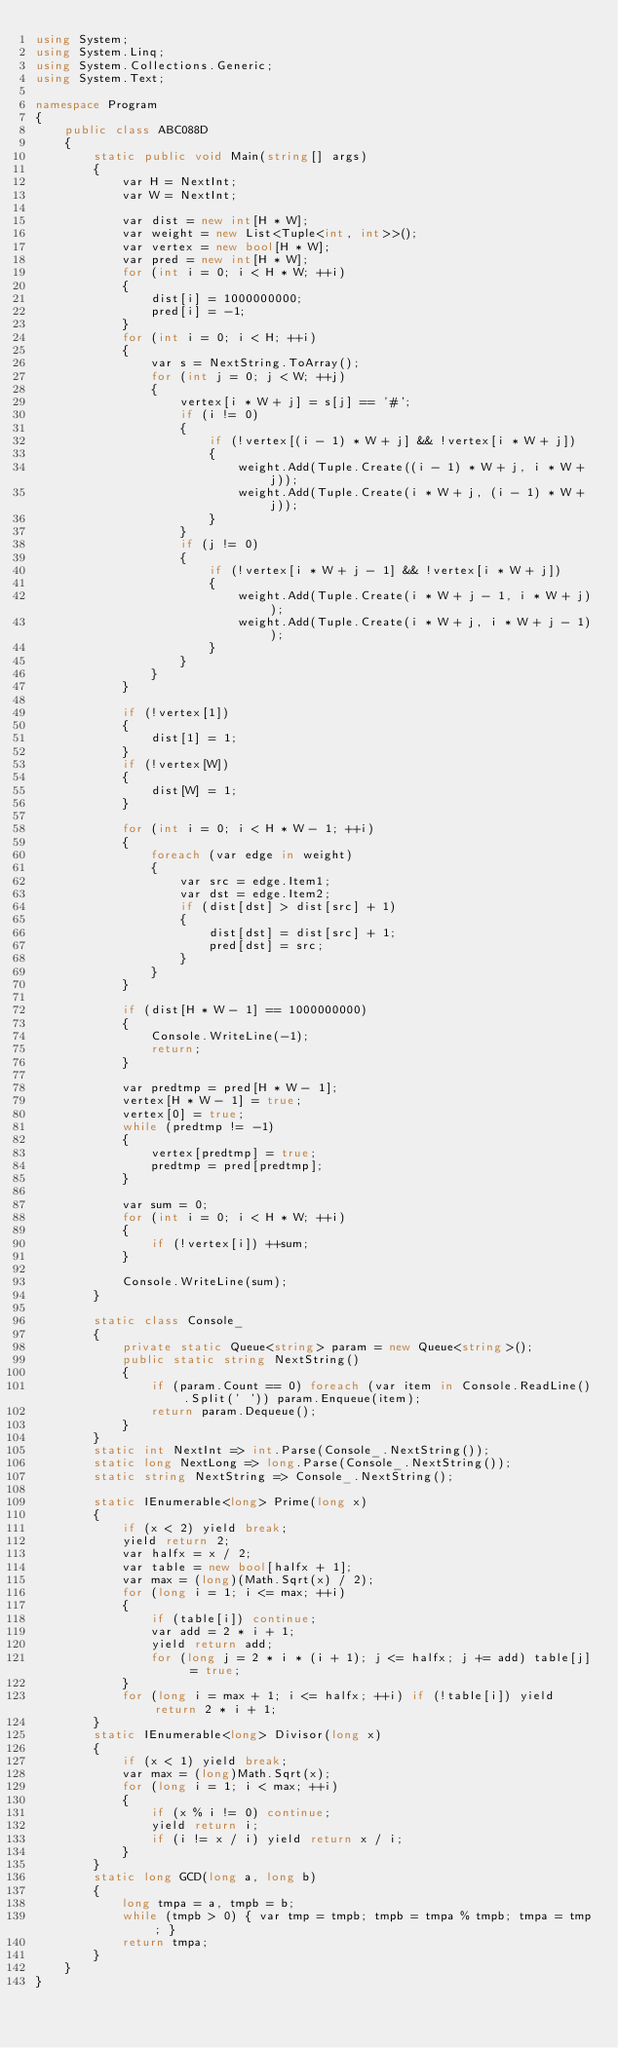Convert code to text. <code><loc_0><loc_0><loc_500><loc_500><_C#_>using System;
using System.Linq;
using System.Collections.Generic;
using System.Text;

namespace Program
{
    public class ABC088D
    {
        static public void Main(string[] args)
        {
            var H = NextInt;
            var W = NextInt;

            var dist = new int[H * W];
            var weight = new List<Tuple<int, int>>();
            var vertex = new bool[H * W];
            var pred = new int[H * W];
            for (int i = 0; i < H * W; ++i)
            {
                dist[i] = 1000000000;
                pred[i] = -1;
            }
            for (int i = 0; i < H; ++i)
            {
                var s = NextString.ToArray();
                for (int j = 0; j < W; ++j)
                {
                    vertex[i * W + j] = s[j] == '#';
                    if (i != 0)
                    {
                        if (!vertex[(i - 1) * W + j] && !vertex[i * W + j])
                        {
                            weight.Add(Tuple.Create((i - 1) * W + j, i * W + j));
                            weight.Add(Tuple.Create(i * W + j, (i - 1) * W + j));
                        }
                    }
                    if (j != 0)
                    {
                        if (!vertex[i * W + j - 1] && !vertex[i * W + j])
                        {
                            weight.Add(Tuple.Create(i * W + j - 1, i * W + j));
                            weight.Add(Tuple.Create(i * W + j, i * W + j - 1));
                        }
                    }
                }
            }

            if (!vertex[1])
            {
                dist[1] = 1;
            }
            if (!vertex[W])
            {
                dist[W] = 1;
            }

            for (int i = 0; i < H * W - 1; ++i)
            {
                foreach (var edge in weight)
                {
                    var src = edge.Item1;
                    var dst = edge.Item2;
                    if (dist[dst] > dist[src] + 1)
                    {
                        dist[dst] = dist[src] + 1;
                        pred[dst] = src;
                    }
                }
            }

            if (dist[H * W - 1] == 1000000000)
            {
                Console.WriteLine(-1);
                return;
            }

            var predtmp = pred[H * W - 1];
            vertex[H * W - 1] = true;
            vertex[0] = true;
            while (predtmp != -1)
            {
                vertex[predtmp] = true;
                predtmp = pred[predtmp];
            }

            var sum = 0;
            for (int i = 0; i < H * W; ++i)
            {
                if (!vertex[i]) ++sum;
            }

            Console.WriteLine(sum);
        }

        static class Console_
        {
            private static Queue<string> param = new Queue<string>();
            public static string NextString()
            {
                if (param.Count == 0) foreach (var item in Console.ReadLine().Split(' ')) param.Enqueue(item);
                return param.Dequeue();
            }
        }
        static int NextInt => int.Parse(Console_.NextString());
        static long NextLong => long.Parse(Console_.NextString());
        static string NextString => Console_.NextString();

        static IEnumerable<long> Prime(long x)
        {
            if (x < 2) yield break;
            yield return 2;
            var halfx = x / 2;
            var table = new bool[halfx + 1];
            var max = (long)(Math.Sqrt(x) / 2);
            for (long i = 1; i <= max; ++i)
            {
                if (table[i]) continue;
                var add = 2 * i + 1;
                yield return add;
                for (long j = 2 * i * (i + 1); j <= halfx; j += add) table[j] = true;
            }
            for (long i = max + 1; i <= halfx; ++i) if (!table[i]) yield return 2 * i + 1;
        }
        static IEnumerable<long> Divisor(long x)
        {
            if (x < 1) yield break;
            var max = (long)Math.Sqrt(x);
            for (long i = 1; i < max; ++i)
            {
                if (x % i != 0) continue;
                yield return i;
                if (i != x / i) yield return x / i;
            }
        }
        static long GCD(long a, long b)
        {
            long tmpa = a, tmpb = b;
            while (tmpb > 0) { var tmp = tmpb; tmpb = tmpa % tmpb; tmpa = tmp; }
            return tmpa;
        }
    }
}
</code> 